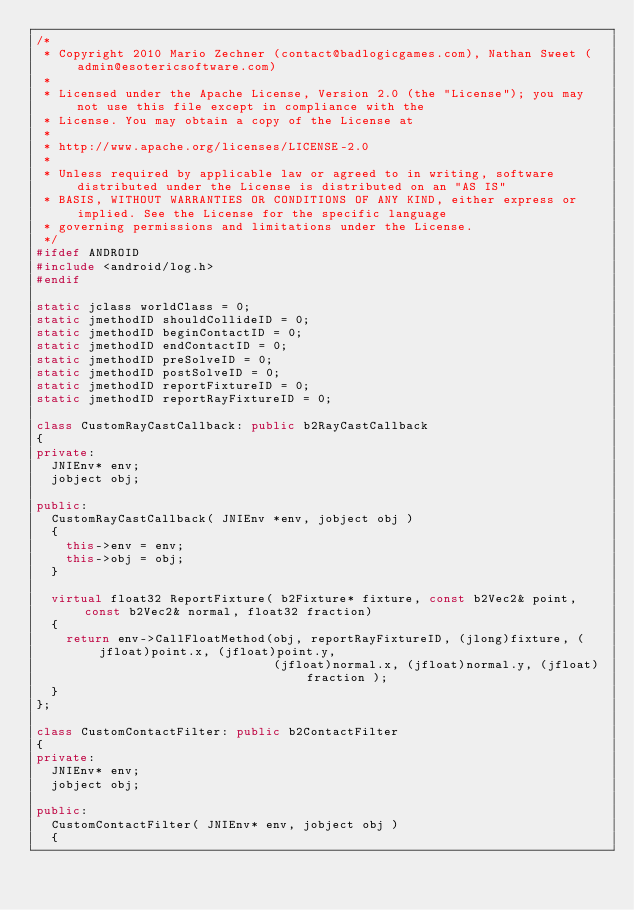Convert code to text. <code><loc_0><loc_0><loc_500><loc_500><_C++_>/*
 * Copyright 2010 Mario Zechner (contact@badlogicgames.com), Nathan Sweet (admin@esotericsoftware.com)
 *
 * Licensed under the Apache License, Version 2.0 (the "License"); you may not use this file except in compliance with the
 * License. You may obtain a copy of the License at
 *
 * http://www.apache.org/licenses/LICENSE-2.0
 *
 * Unless required by applicable law or agreed to in writing, software distributed under the License is distributed on an "AS IS"
 * BASIS, WITHOUT WARRANTIES OR CONDITIONS OF ANY KIND, either express or implied. See the License for the specific language
 * governing permissions and limitations under the License.
 */
#ifdef ANDROID
#include <android/log.h>
#endif

static jclass worldClass = 0;
static jmethodID shouldCollideID = 0;
static jmethodID beginContactID = 0;
static jmethodID endContactID = 0;
static jmethodID preSolveID = 0;
static jmethodID postSolveID = 0;
static jmethodID reportFixtureID = 0;
static jmethodID reportRayFixtureID = 0;

class CustomRayCastCallback: public b2RayCastCallback
{
private:
	JNIEnv* env;
	jobject obj;

public:
	CustomRayCastCallback( JNIEnv *env, jobject obj )
	{
		this->env = env;
		this->obj = obj;
	}

	virtual float32 ReportFixture( b2Fixture* fixture, const b2Vec2& point, const b2Vec2& normal, float32 fraction)
	{
		return env->CallFloatMethod(obj, reportRayFixtureID, (jlong)fixture, (jfloat)point.x, (jfloat)point.y,
																(jfloat)normal.x, (jfloat)normal.y, (jfloat)fraction );
	}
};

class CustomContactFilter: public b2ContactFilter
{
private:
	JNIEnv* env;
	jobject obj;

public:
	CustomContactFilter( JNIEnv* env, jobject obj )
	{</code> 